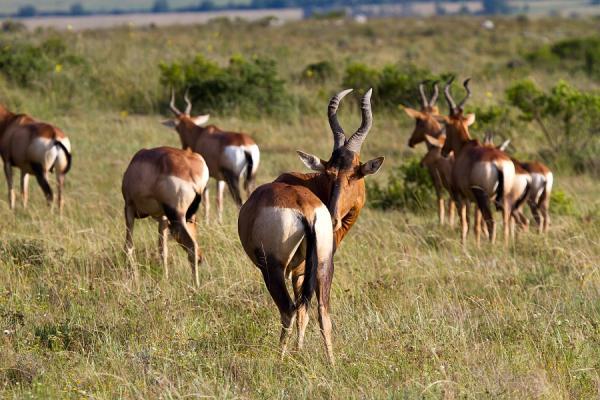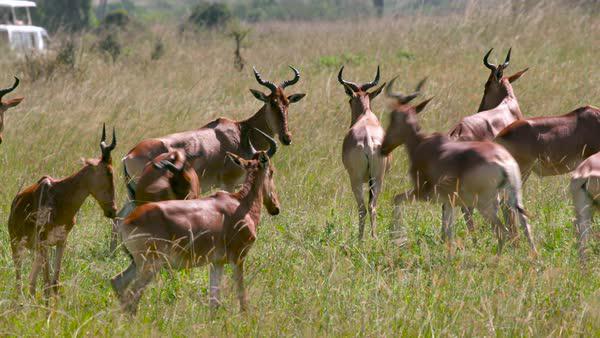The first image is the image on the left, the second image is the image on the right. For the images displayed, is the sentence "One of the images has exactly two animals in it." factually correct? Answer yes or no. No. 